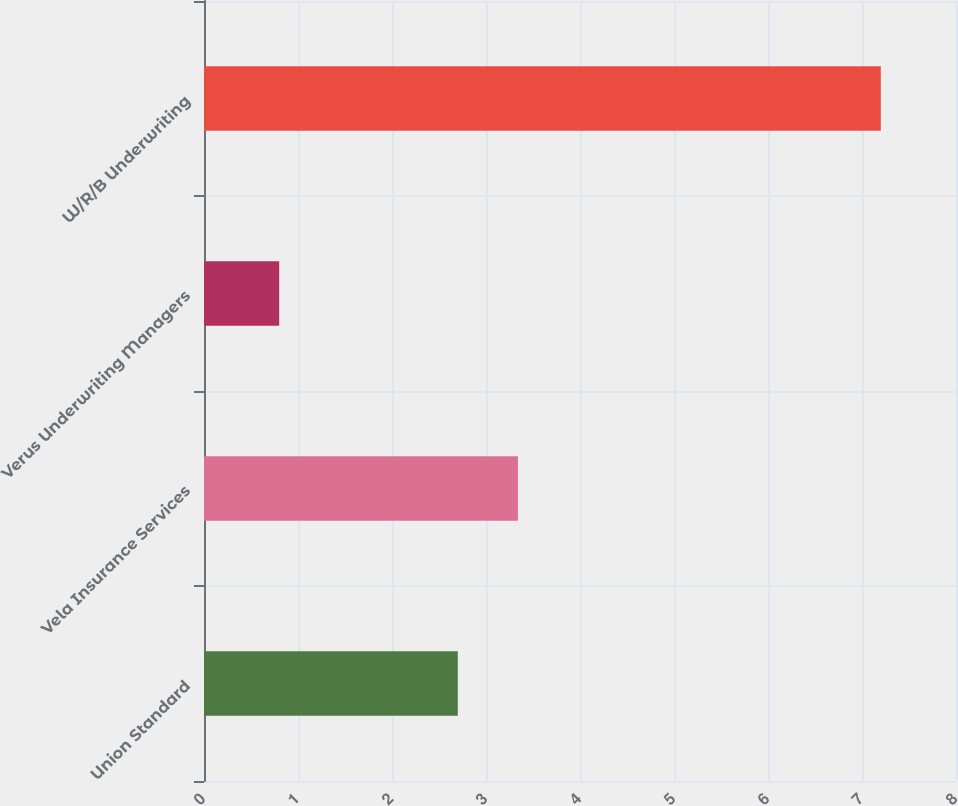<chart> <loc_0><loc_0><loc_500><loc_500><bar_chart><fcel>Union Standard<fcel>Vela Insurance Services<fcel>Verus Underwriting Managers<fcel>W/R/B Underwriting<nl><fcel>2.7<fcel>3.34<fcel>0.8<fcel>7.2<nl></chart> 